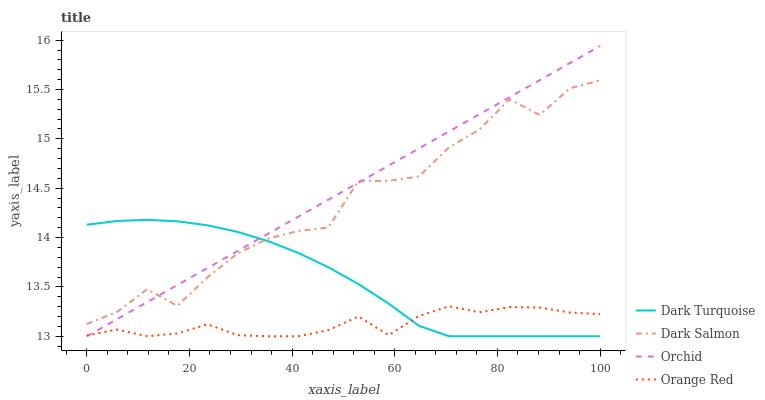Does Orange Red have the minimum area under the curve?
Answer yes or no. Yes. Does Orchid have the maximum area under the curve?
Answer yes or no. Yes. Does Dark Salmon have the minimum area under the curve?
Answer yes or no. No. Does Dark Salmon have the maximum area under the curve?
Answer yes or no. No. Is Orchid the smoothest?
Answer yes or no. Yes. Is Dark Salmon the roughest?
Answer yes or no. Yes. Is Orange Red the smoothest?
Answer yes or no. No. Is Orange Red the roughest?
Answer yes or no. No. Does Dark Turquoise have the lowest value?
Answer yes or no. Yes. Does Dark Salmon have the lowest value?
Answer yes or no. No. Does Orchid have the highest value?
Answer yes or no. Yes. Does Dark Salmon have the highest value?
Answer yes or no. No. Is Orange Red less than Dark Salmon?
Answer yes or no. Yes. Is Dark Salmon greater than Orange Red?
Answer yes or no. Yes. Does Orchid intersect Dark Turquoise?
Answer yes or no. Yes. Is Orchid less than Dark Turquoise?
Answer yes or no. No. Is Orchid greater than Dark Turquoise?
Answer yes or no. No. Does Orange Red intersect Dark Salmon?
Answer yes or no. No. 